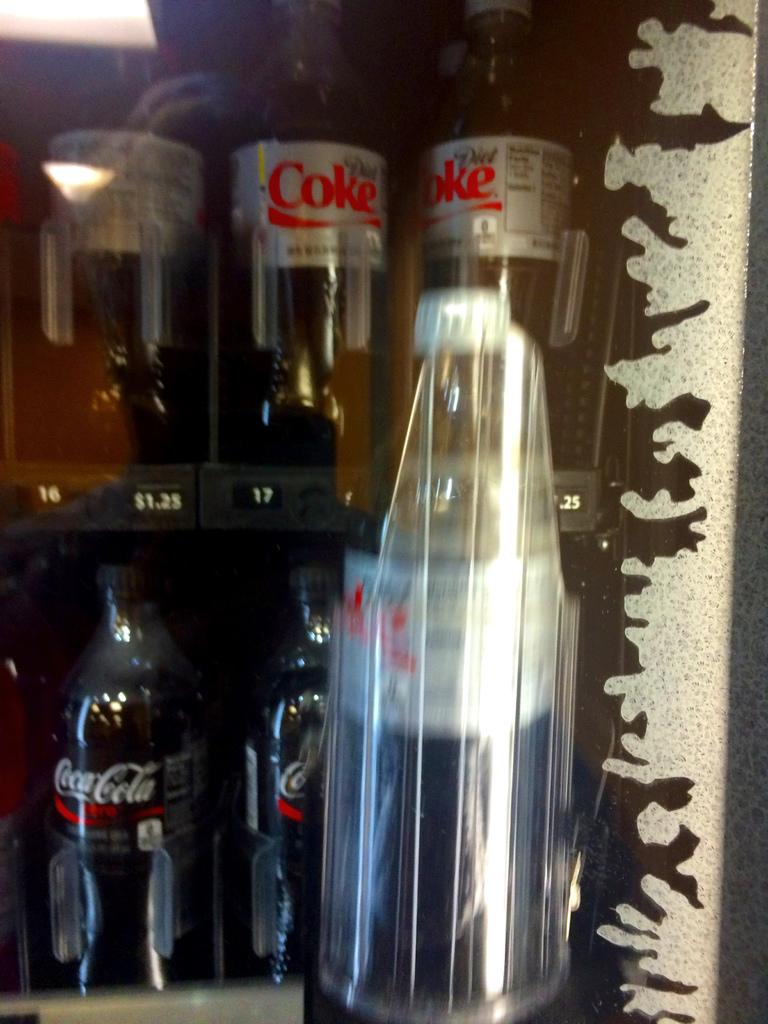What brand of soda is in the background?
Make the answer very short. Coca cola. How much does a diet coke cost?
Keep it short and to the point. $1.25. 